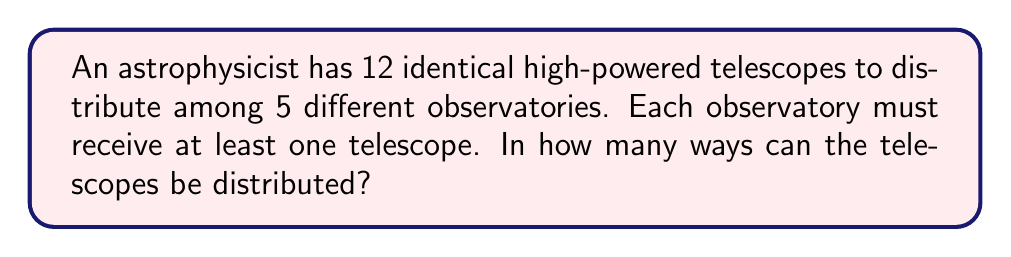Show me your answer to this math problem. Let's approach this step-by-step:

1) This is a problem of distributing identical objects (telescopes) into distinct boxes (observatories) with a minimum condition.

2) We can use the concept of stars and bars (or balls and urns) with a slight modification.

3) First, we need to ensure each observatory gets at least one telescope. We can do this by giving one telescope to each observatory first. This leaves us with 7 telescopes to distribute (12 - 5 = 7).

4) Now, we need to distribute these 7 remaining telescopes among 5 observatories, with no restrictions.

5) This is a classic stars and bars problem. The formula for this is:

   $${n+k-1 \choose k-1}$$

   Where $n$ is the number of identical objects and $k$ is the number of distinct boxes.

6) In our case, $n = 7$ (remaining telescopes) and $k = 5$ (observatories).

7) Plugging these values into the formula:

   $${7+5-1 \choose 5-1} = {11 \choose 4}$$

8) We can calculate this:

   $$\frac{11!}{4!(11-4)!} = \frac{11!}{4!7!} = 330$$

Therefore, there are 330 ways to distribute the telescopes.
Answer: 330 